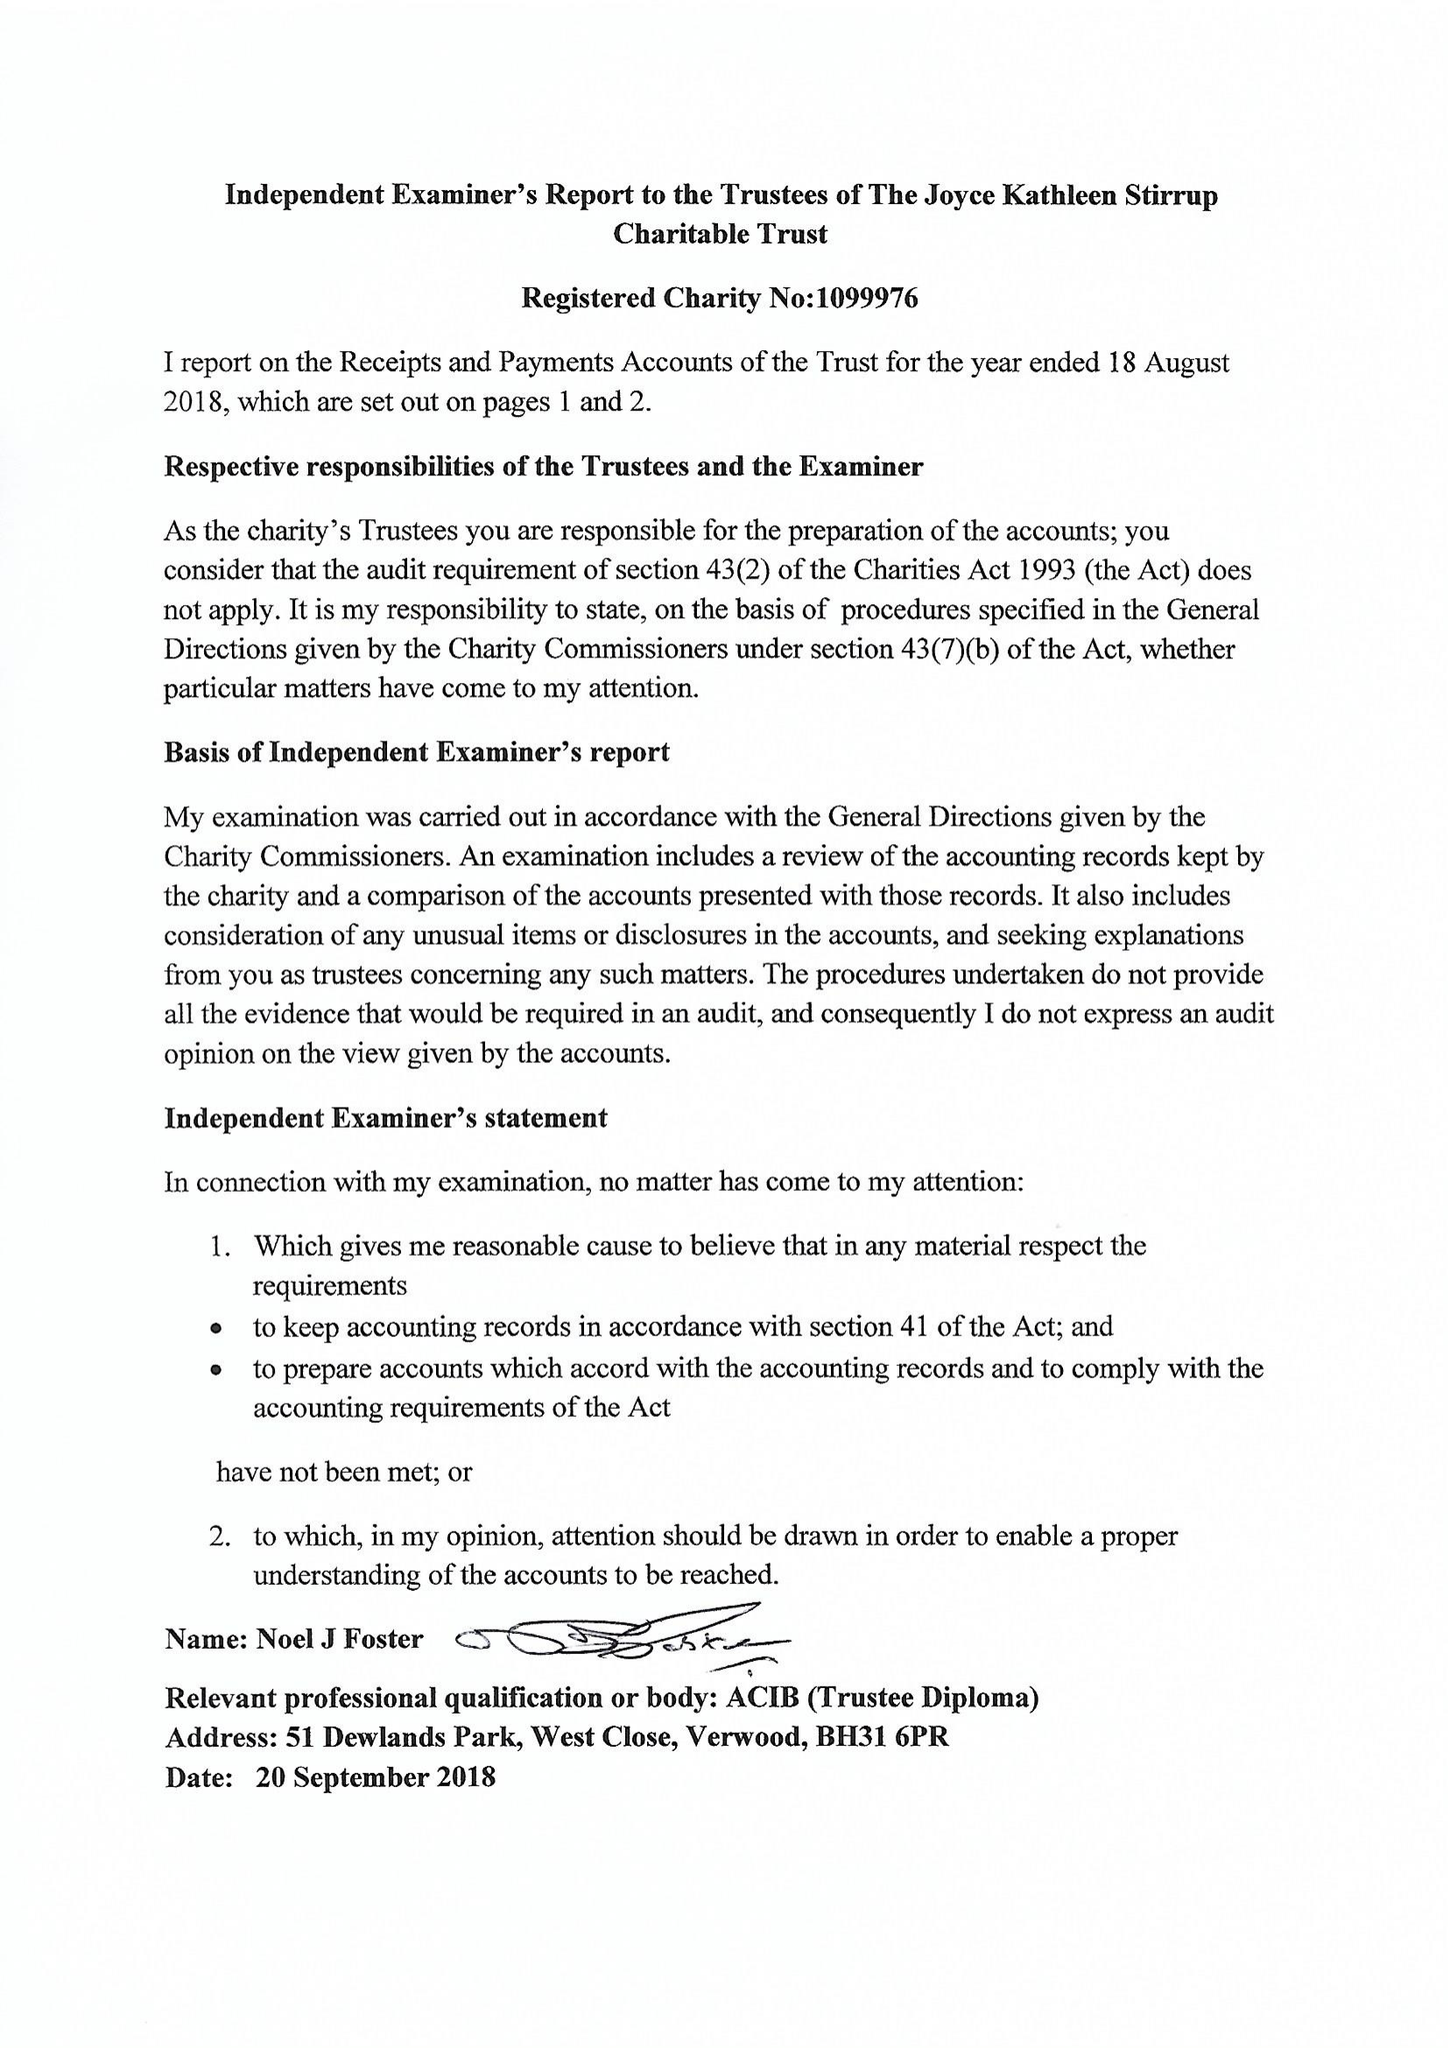What is the value for the report_date?
Answer the question using a single word or phrase. 2018-08-18 